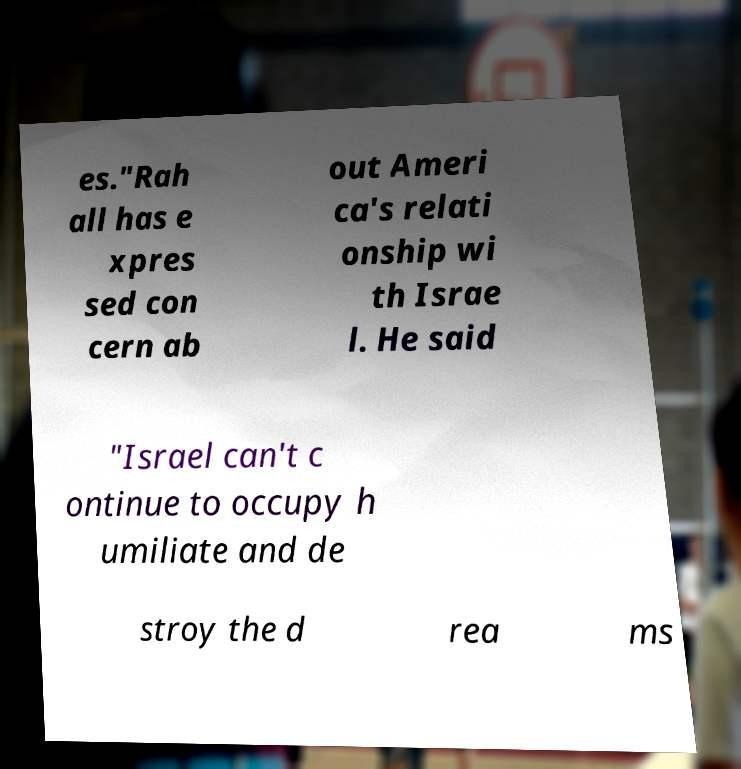Please read and relay the text visible in this image. What does it say? es."Rah all has e xpres sed con cern ab out Ameri ca's relati onship wi th Israe l. He said "Israel can't c ontinue to occupy h umiliate and de stroy the d rea ms 